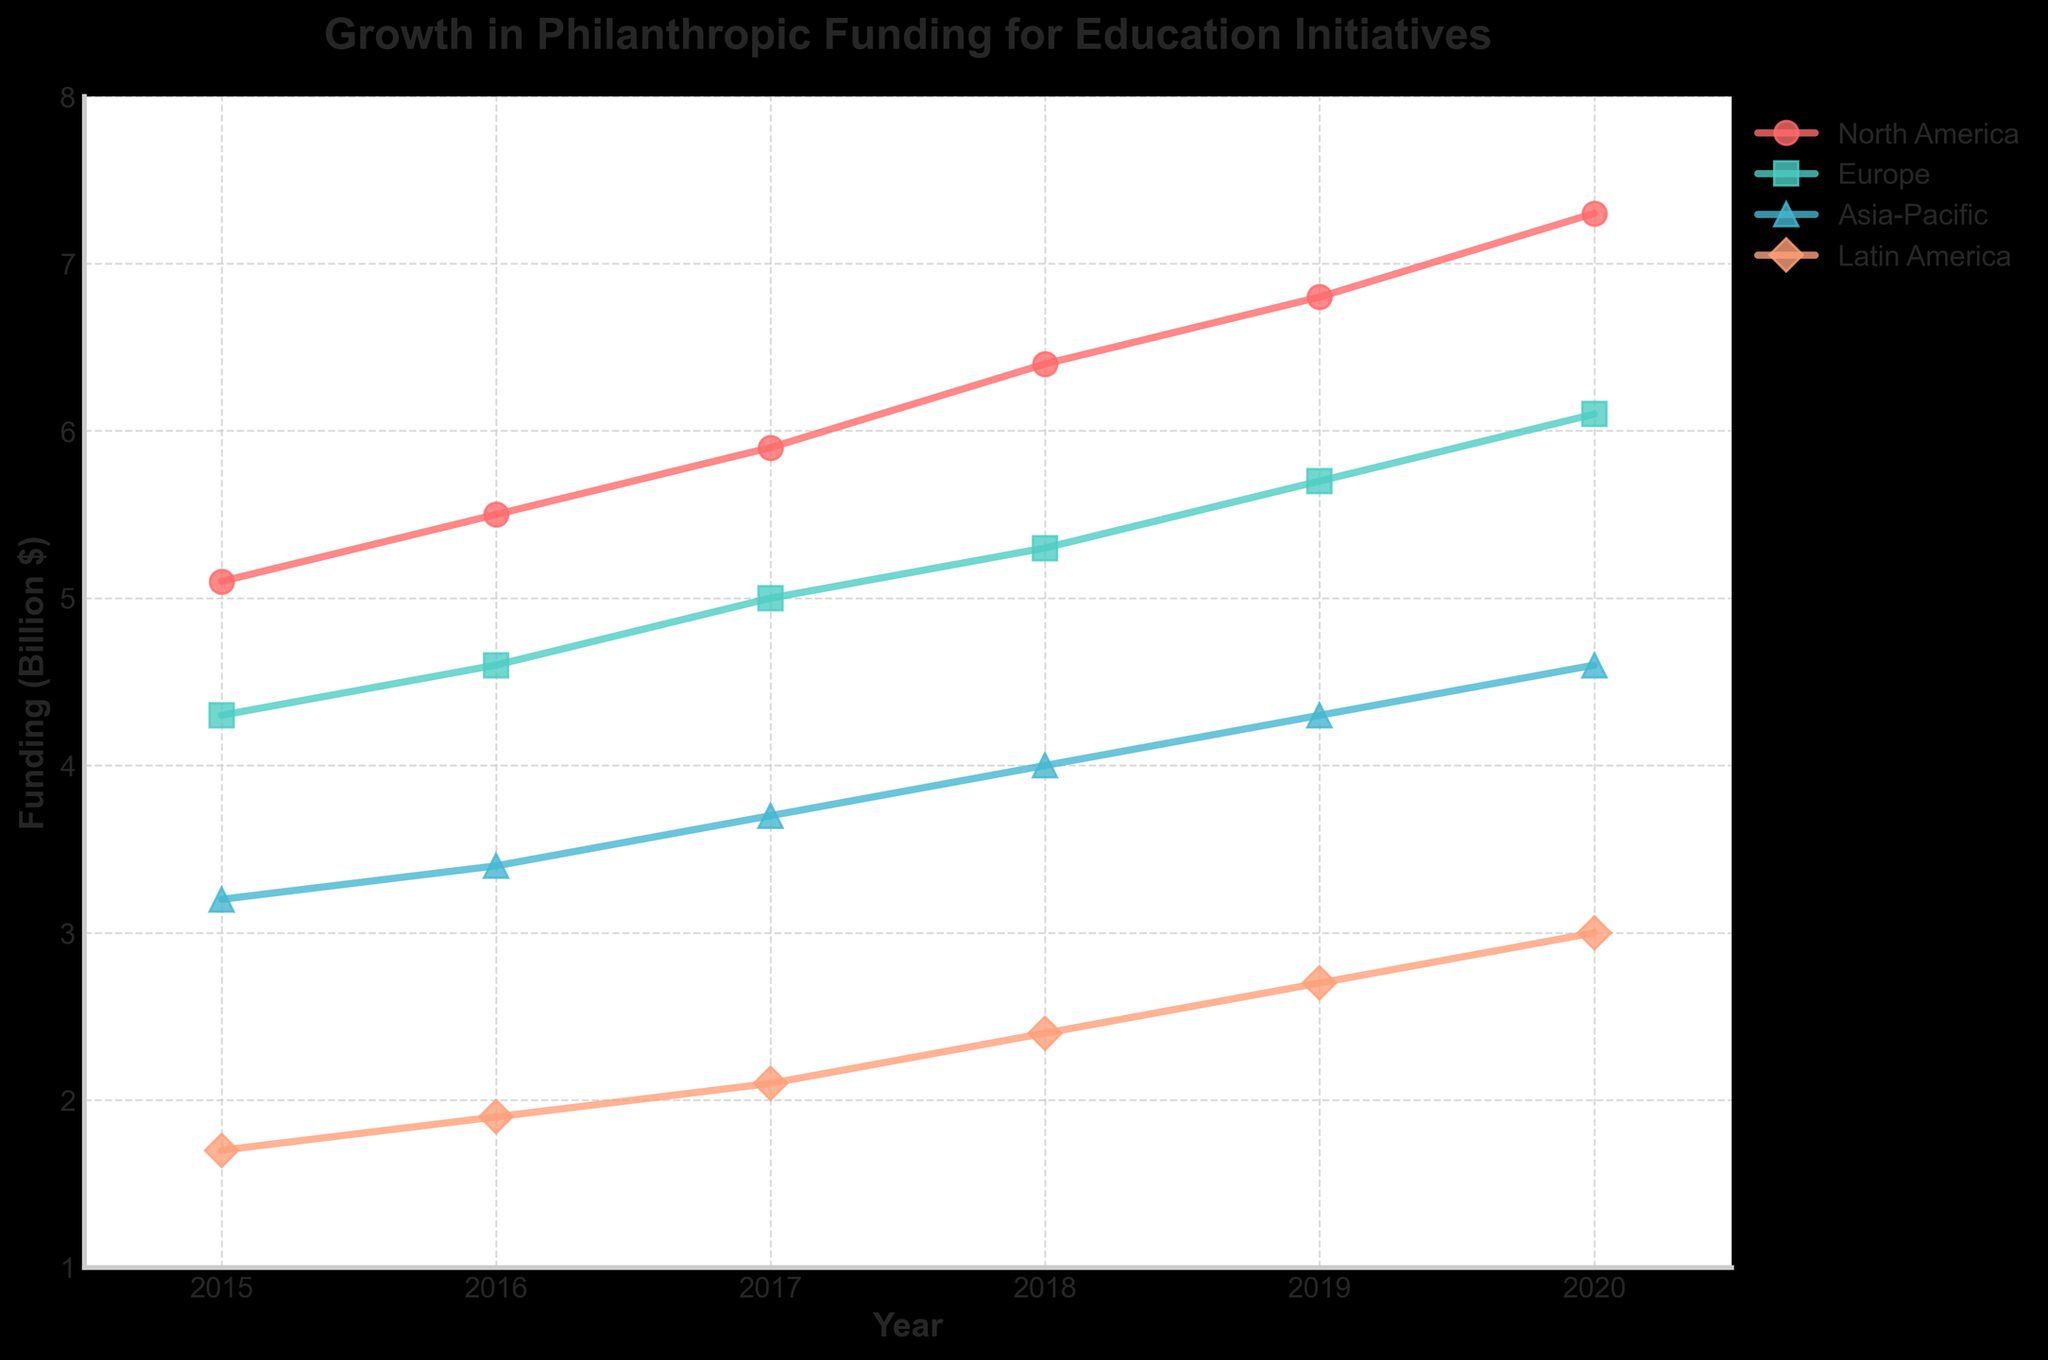What's the title of the plot? The title is typically shown at the top of the plot. Here, it is written in bold and larger font compared to the other text on the plot.
Answer: Growth in Philanthropic Funding for Education Initiatives How many geographical regions are represented in the plot? You can count the unique legend entries on the plot, or notice the distinct colors and markers representing each region.
Answer: Four Which region had the highest funding in 2020? Locate the year 2020 on the x-axis and compare the values for each region. The highest value will indicate the region with the highest funding.
Answer: North America What is the range of funding amounts for the Asia-Pacific region during the given period? Locate data points for Asia-Pacific across all years and note the minimum and maximum values on the y-axis.
Answer: 3.2 to 4.6 billion $ How did funding in Latin America trend from 2015 to 2020? Follow the data points for Latin America from 2015 to 2020. Observe the direction and changes in funding amounts.
Answer: Increased steadily Which region showed the biggest increase in funding from 2015 to 2020? For each region, subtract the 2015 funding amount from the 2020 funding amount. Compare these results to determine the largest increase.
Answer: North America Was there any year where Europe matched or exceeded the funding level of North America? Examine the plot and compare values between Europe and North America for each year. Determine if their funding levels matched or if Europe exceeded North America's funding in any year.
Answer: No Between which consecutive years did Europe see the largest increase in funding? Calculate the difference in funding amounts between consecutive years for Europe. Identify the pair of years with the largest increase.
Answer: 2019-2020 In which year did Asia-Pacific reach 4 billion dollars in funding? Trace the Asia-Pacific data points and look for the year where the funding reached exactly or surpassed the 4 billion dollars mark for the first time.
Answer: 2018 What was the funding amount for Latin America in 2017? Locate the data point for Latin America in 2017 and read the corresponding value on the y-axis.
Answer: 2.1 billion $ 